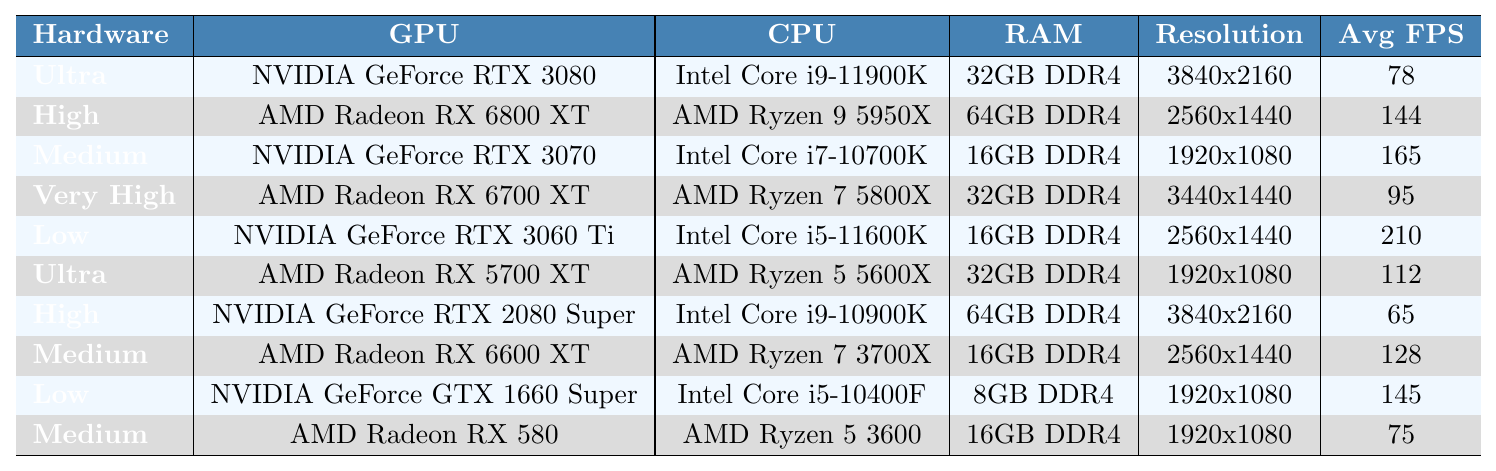What is the average frame rate for the configuration with Ultra graphics settings? In the table, there is only one row with Ultra graphics settings, which corresponds to the NVIDIA GeForce RTX 3080, showing an average frame rate of 78.
Answer: 78 Which hardware configuration provides the highest average frame rate? The row with the NVIDIA GeForce RTX 3060 Ti features the highest average frame rate of 210, which is more than any other configuration listed.
Answer: 210 Is the average frame rate for the AMD Radeon RX 6700 XT higher than that of the NVIDIA GeForce RTX 2080 Super? The AMD Radeon RX 6700 XT has an average frame rate of 95, while the NVIDIA GeForce RTX 2080 Super has an average of 65, therefore the RX 6700 XT is indeed higher.
Answer: Yes How many configurations achieve an average frame rate above 100? By inspecting the table, we find that the following configurations have average frame rates above 100: AMD Radeon RX 6800 XT (144), NVIDIA GeForce RTX 3070 (165), NVIDIA GeForce RTX 3060 Ti (210), AMD Radeon RX 5700 XT (112), and AMD Radeon RX 6600 XT (128). This makes a total of 5 configurations.
Answer: 5 What is the average frame rate of all the configurations listed in the table? First, sum the average frame rates: 78 + 144 + 165 + 95 + 210 + 112 + 65 + 128 + 145 + 75 = 1,932. Then, divide this sum by the number of configurations (10): 1,932 / 10 = 193.2. Therefore, the average frame rate of all configurations is 193.2.
Answer: 193.2 Which GPU achieves the best performance at 2560x1440 resolution? At 2560x1440 resolution, the AMD Radeon RX 6800 XT achieves an average frame rate of 144, which is higher than the NVIDIA GeForce RTX 3060 Ti (210 at 2560x1440). Considering FPS, we should look at the same resolution across GPUs. The RX 6800 XT wins for its resolution, as other configurations are either lower resolution or provide lower frame rates despite the GTX 1660 Super being higher at a lower resolution.
Answer: AMD Radeon RX 6800 XT Which configurations have an Intel CPU with a frame rate of 150 or higher? The configurations with Intel CPUs that have an average frame rate of 150 or higher are: NVIDIA GeForce RTX 3070 (165) and NVIDIA GeForce RTX 3060 Ti (210). These are the only configurations meeting the criteria.
Answer: 2 Is the frame rate for AMD GPUs generally higher than those for NVIDIA GPUs? To determine this, we compare the average frame rates for AMD GPUs (144, 165, 95, 112, 128, and 75) versus NVIDIA GPUs (78, 165, 210, 65, and 145). The average for AMD is approximately 111.67 while NVIDIA has an average of about 117.4. Therefore, it is not true that AMD GPUs generally have higher frame rates as NVIDIA has a slight lead.
Answer: No What resolution setting corresponds to the lowest average frame rate in the table? The NVIDIA GeForce RTX 2080 Super at 3840x2160 resolution has the lowest average frame rate of 65 in the table.
Answer: 3840x2160 How does the average frame rate of the configuration with Low graphics settings compare to the highest setting? The configuration with Low graphics settings (NVIDIA GeForce RTX 3060 Ti) has an average frame rate of 210, which is much higher than the highest configured settings of 165 (for NVIDIA GeForce RTX 3070 at Medium), and the Ultra settings which only yield 78 FPS.
Answer: Higher 